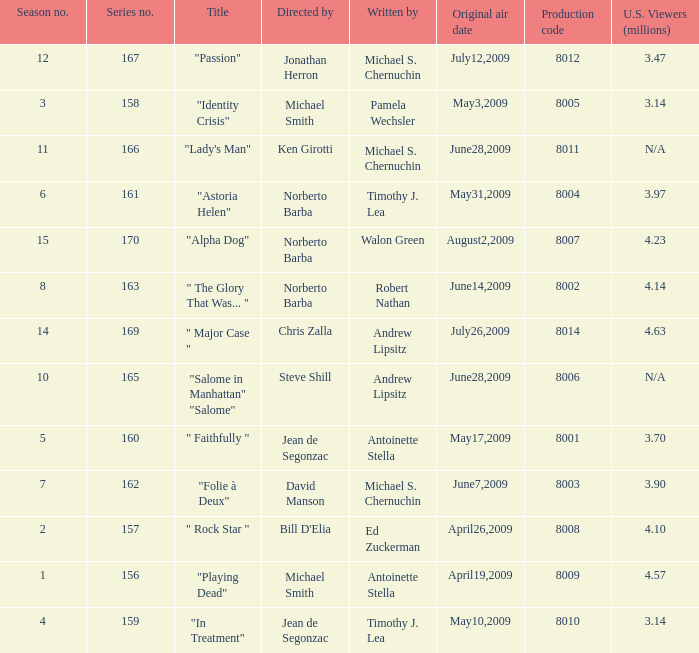Can you give me this table as a dict? {'header': ['Season no.', 'Series no.', 'Title', 'Directed by', 'Written by', 'Original air date', 'Production code', 'U.S. Viewers (millions)'], 'rows': [['12', '167', '"Passion"', 'Jonathan Herron', 'Michael S. Chernuchin', 'July12,2009', '8012', '3.47'], ['3', '158', '"Identity Crisis"', 'Michael Smith', 'Pamela Wechsler', 'May3,2009', '8005', '3.14'], ['11', '166', '"Lady\'s Man"', 'Ken Girotti', 'Michael S. Chernuchin', 'June28,2009', '8011', 'N/A'], ['6', '161', '"Astoria Helen"', 'Norberto Barba', 'Timothy J. Lea', 'May31,2009', '8004', '3.97'], ['15', '170', '"Alpha Dog"', 'Norberto Barba', 'Walon Green', 'August2,2009', '8007', '4.23'], ['8', '163', '" The Glory That Was... "', 'Norberto Barba', 'Robert Nathan', 'June14,2009', '8002', '4.14'], ['14', '169', '" Major Case "', 'Chris Zalla', 'Andrew Lipsitz', 'July26,2009', '8014', '4.63'], ['10', '165', '"Salome in Manhattan" "Salome"', 'Steve Shill', 'Andrew Lipsitz', 'June28,2009', '8006', 'N/A'], ['5', '160', '" Faithfully "', 'Jean de Segonzac', 'Antoinette Stella', 'May17,2009', '8001', '3.70'], ['7', '162', '"Folie à Deux"', 'David Manson', 'Michael S. Chernuchin', 'June7,2009', '8003', '3.90'], ['2', '157', '" Rock Star "', "Bill D'Elia", 'Ed Zuckerman', 'April26,2009', '8008', '4.10'], ['1', '156', '"Playing Dead"', 'Michael Smith', 'Antoinette Stella', 'April19,2009', '8009', '4.57'], ['4', '159', '"In Treatment"', 'Jean de Segonzac', 'Timothy J. Lea', 'May10,2009', '8010', '3.14']]} Which is the  maximun serie episode number when the millions of north american spectators is 3.14? 159.0. 